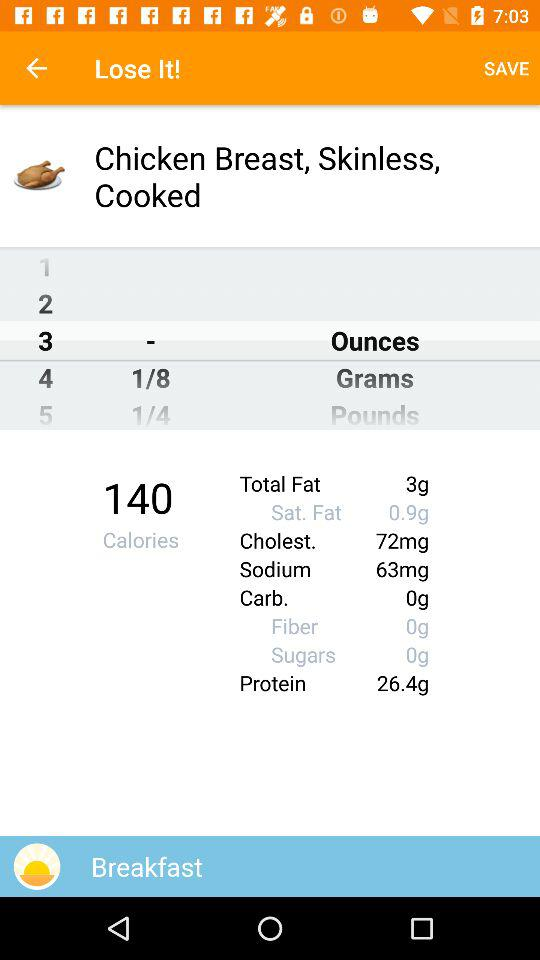How many calories in total are there? There are 140 calories in total. 